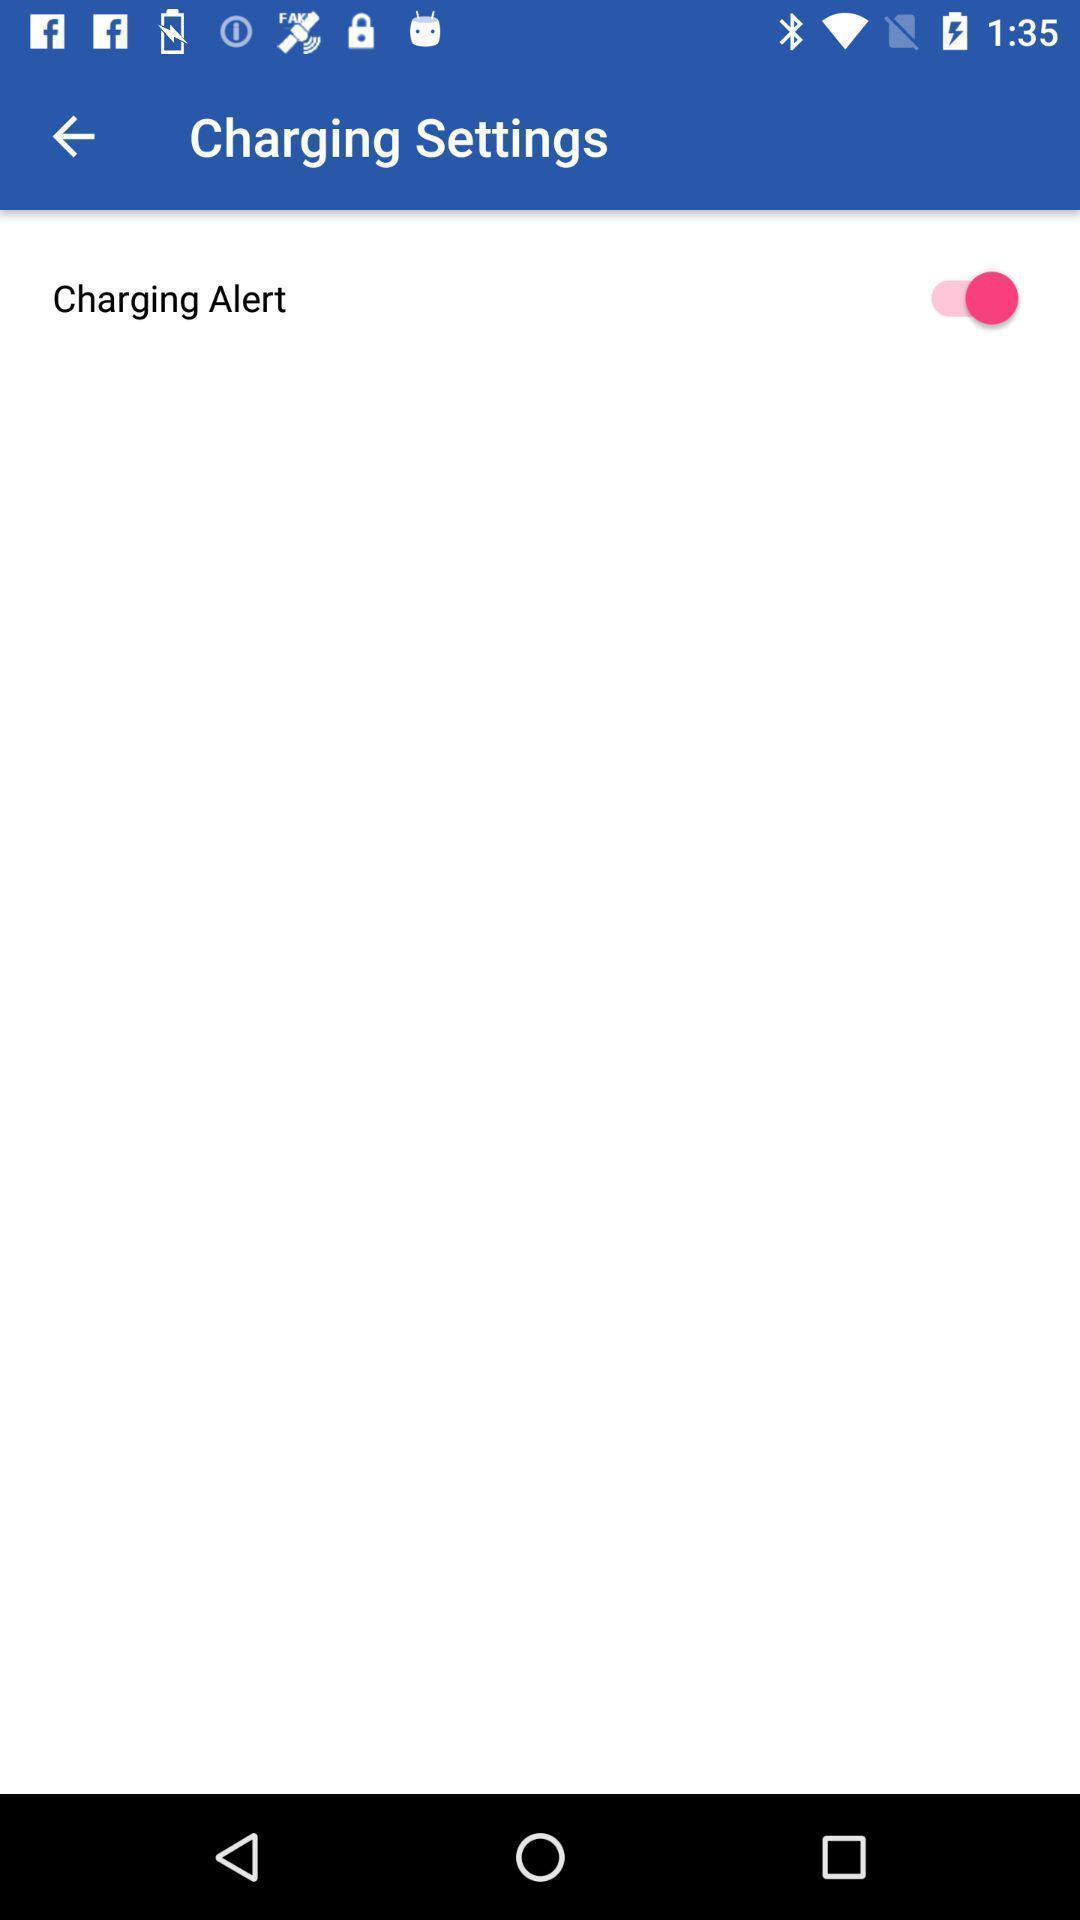What can you discern from this picture? Settings page with one option to enable or disable. 